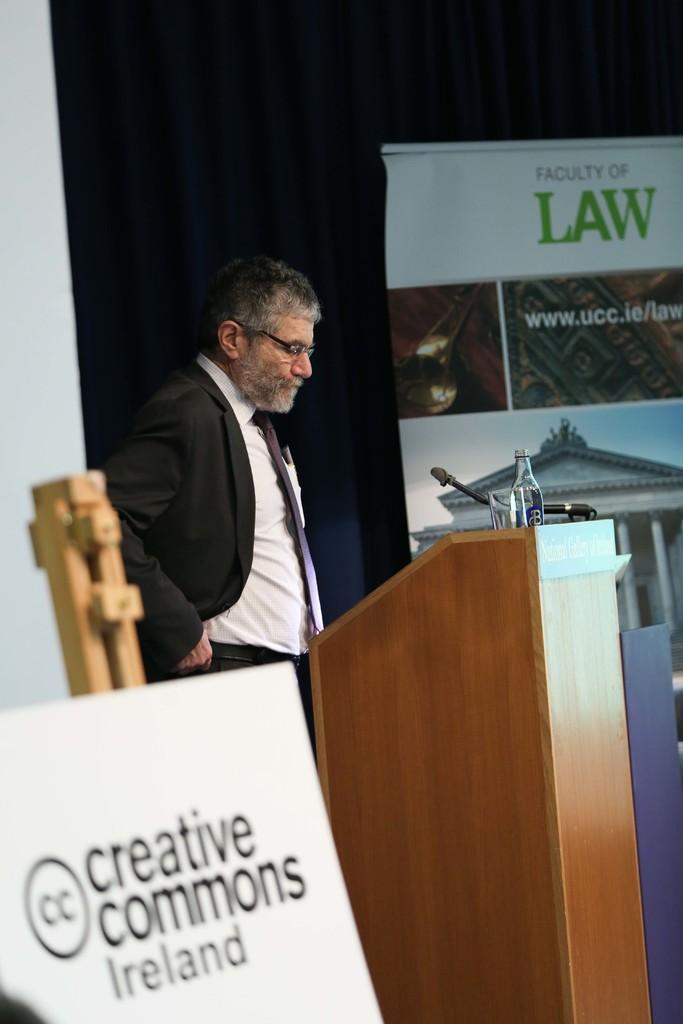In one or two sentences, can you explain what this image depicts? In this picture we can see a name board and a person, in front of him we can see a podium, mic, bottle and in the background we can see a curtain, poster. 